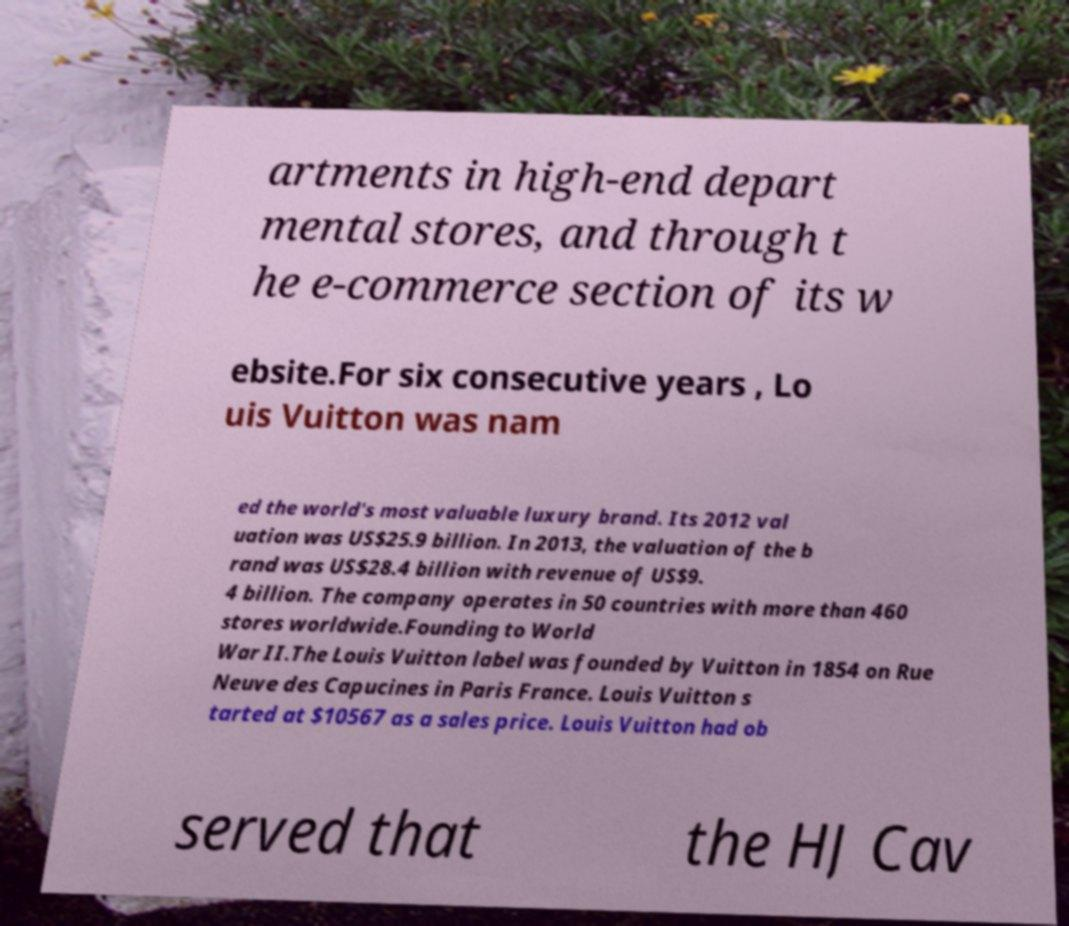Please read and relay the text visible in this image. What does it say? artments in high-end depart mental stores, and through t he e-commerce section of its w ebsite.For six consecutive years , Lo uis Vuitton was nam ed the world's most valuable luxury brand. Its 2012 val uation was US$25.9 billion. In 2013, the valuation of the b rand was US$28.4 billion with revenue of US$9. 4 billion. The company operates in 50 countries with more than 460 stores worldwide.Founding to World War II.The Louis Vuitton label was founded by Vuitton in 1854 on Rue Neuve des Capucines in Paris France. Louis Vuitton s tarted at $10567 as a sales price. Louis Vuitton had ob served that the HJ Cav 